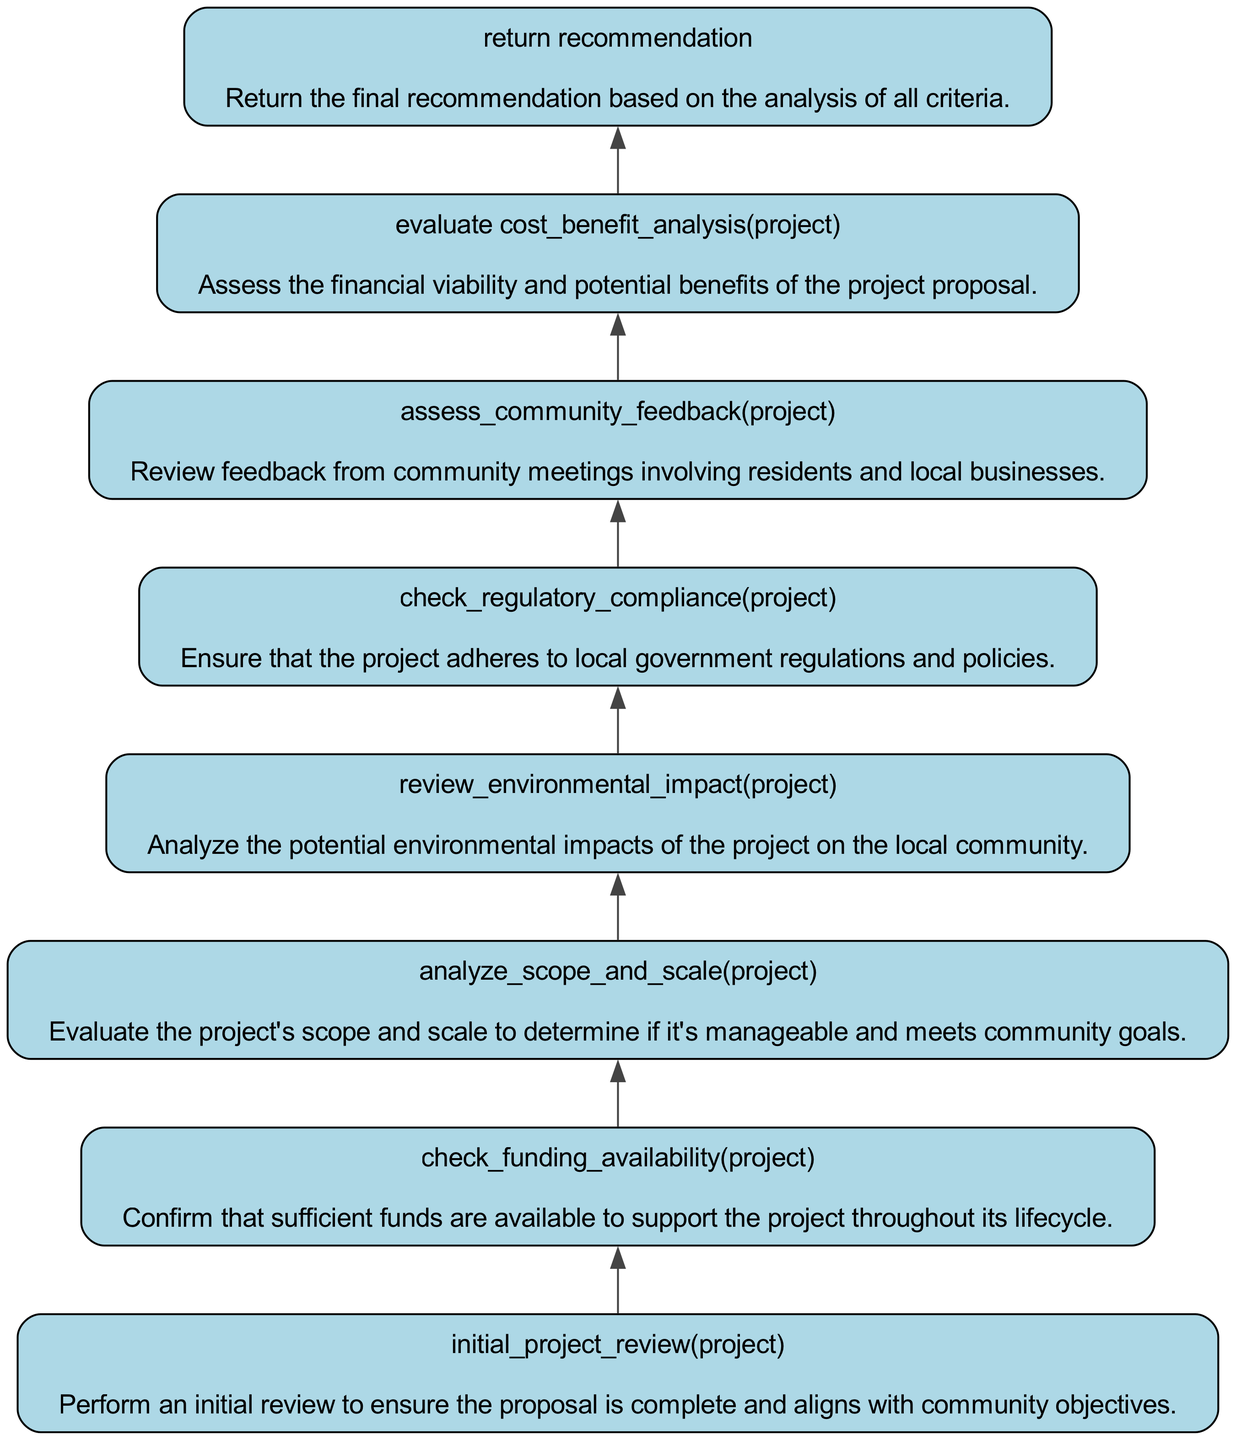What is the first step in the analysis process? The first step in the analysis process according to the flowchart is "initial_project_review(project)," which involves performing an initial review to ensure that the proposal is complete and aligns with community objectives.
Answer: initial project review How many nodes are in the diagram? The diagram consists of a total of eight nodes, each representing a different step in the community project proposal analysis.
Answer: eight What criteria are assessed before the final recommendation? Before making a final recommendation, the criteria assessed are: cost-benefit analysis, community feedback, regulatory compliance, environmental impact, scope and scale, funding availability, and an initial project review.
Answer: all criteria Which step checks for sufficient funds? The step that checks for sufficient funds is "check_funding_availability(project)," ensuring that adequate funding is available to support the project throughout its lifecycle.
Answer: check funding availability What step follows the community feedback assessment? Following the community feedback assessment ("assess_community_feedback(project)"), the next step is to "check_regulatory_compliance(project)." This sequential flow indicates regulatory compliance analysis comes after reviewing community input.
Answer: check regulatory compliance What is the purpose of the "analyze_scope_and_scale(project)" step? The purpose of the "analyze_scope_and_scale(project)" step is to evaluate the project's scope and scale, determining if it’s manageable and aligns with community goals.
Answer: evaluate project scope and scale What step is performed immediately before returning a recommendation? The step that is performed immediately before returning a recommendation is "evaluate cost_benefit_analysis(project)," as it assesses the financial viability and potential benefits of the project proposal.
Answer: evaluate cost-benefit analysis What is the main focus of the "review_environmental_impact(project)" step? The main focus of the "review_environmental_impact(project)" step is analyzing the potential environmental impacts of the project on the local community.
Answer: analyze environmental impacts 